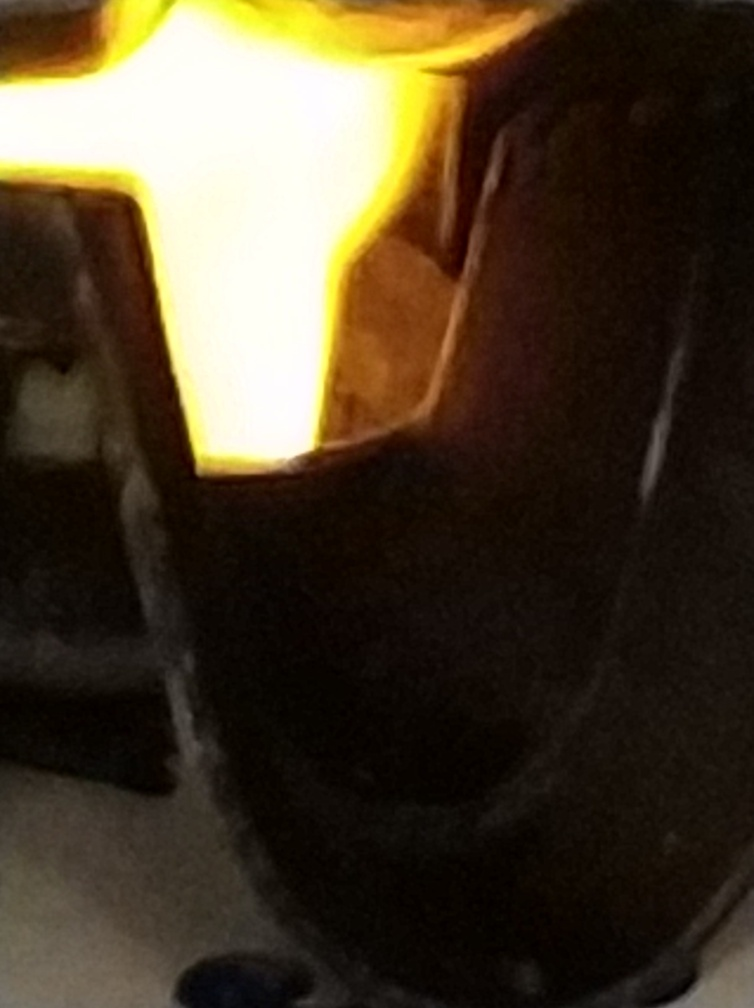What mood does this image evoke? Despite the image's lack of clarity, the stark contrast between the darkness and the bright light in the center may evoke a sense of mystery or intrigue. It could also be perceived as atmospheric, potentially creating a suspenseful or dramatic effect. Could you suggest how this photo could be improved? To improve this photo, one could start by stabilizing the camera to avoid blurriness, using a lower exposure setting to reduce the glare, and ensuring a balanced composition to bring the subject into focus. Proper lighting techniques using diffusers or reflectors could also help even out the light distribution and showcase the colors more naturally. 